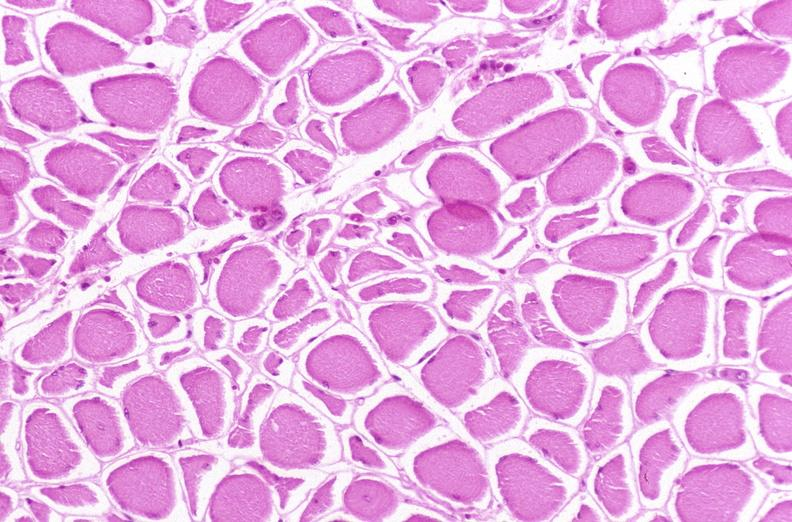what does this image show?
Answer the question using a single word or phrase. Skeletal muscle 